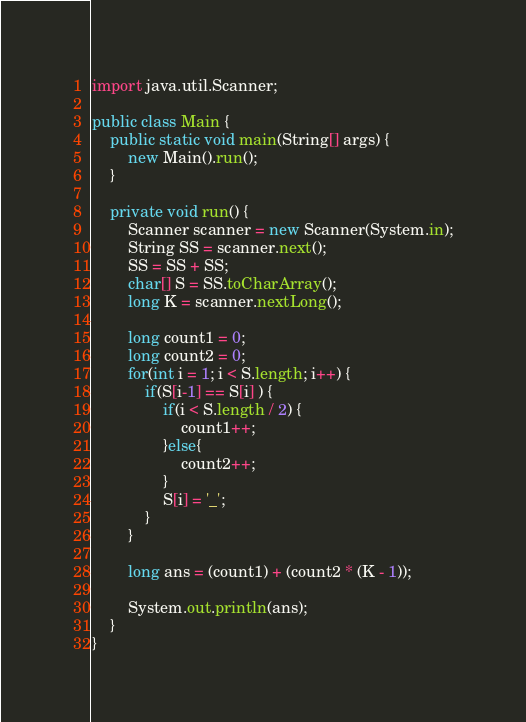<code> <loc_0><loc_0><loc_500><loc_500><_Java_>import java.util.Scanner;

public class Main {
    public static void main(String[] args) {
        new Main().run();
    }

    private void run() {
        Scanner scanner = new Scanner(System.in);
        String SS = scanner.next();
        SS = SS + SS;
        char[] S = SS.toCharArray();
        long K = scanner.nextLong();

        long count1 = 0;
        long count2 = 0;
        for(int i = 1; i < S.length; i++) {
            if(S[i-1] == S[i] ) {
                if(i < S.length / 2) {
                    count1++;
                }else{
                    count2++;
                }
                S[i] = '_';
            }
        }

        long ans = (count1) + (count2 * (K - 1));

        System.out.println(ans);
    }
}</code> 